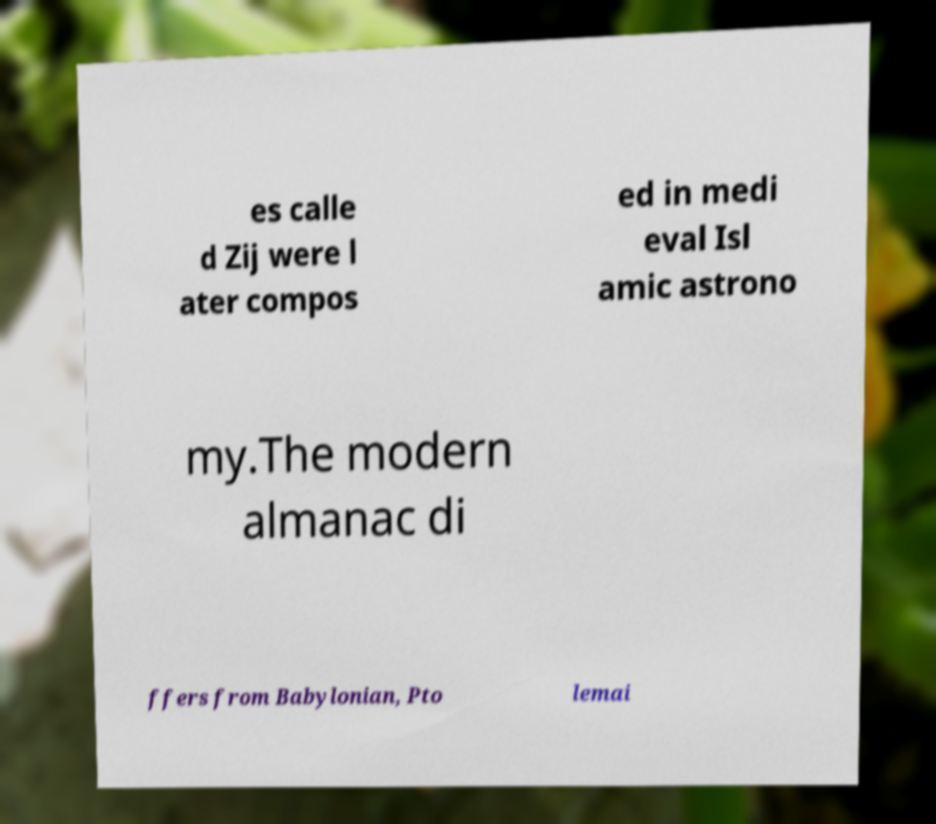For documentation purposes, I need the text within this image transcribed. Could you provide that? es calle d Zij were l ater compos ed in medi eval Isl amic astrono my.The modern almanac di ffers from Babylonian, Pto lemai 